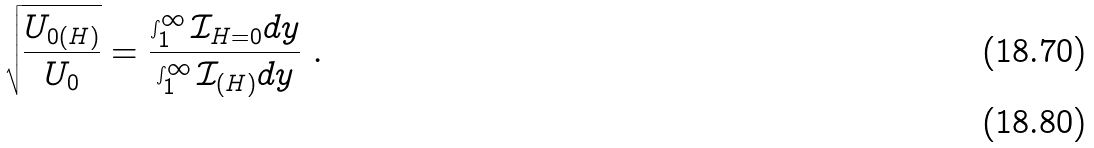<formula> <loc_0><loc_0><loc_500><loc_500>\sqrt { \frac { U _ { 0 ( H ) } } { U _ { 0 } } } = \frac { \int _ { 1 } ^ { \infty } \mathcal { I } _ { H = 0 } d y } { \int _ { 1 } ^ { \infty } \mathcal { I } _ { ( H ) } d y } \ . \\</formula> 